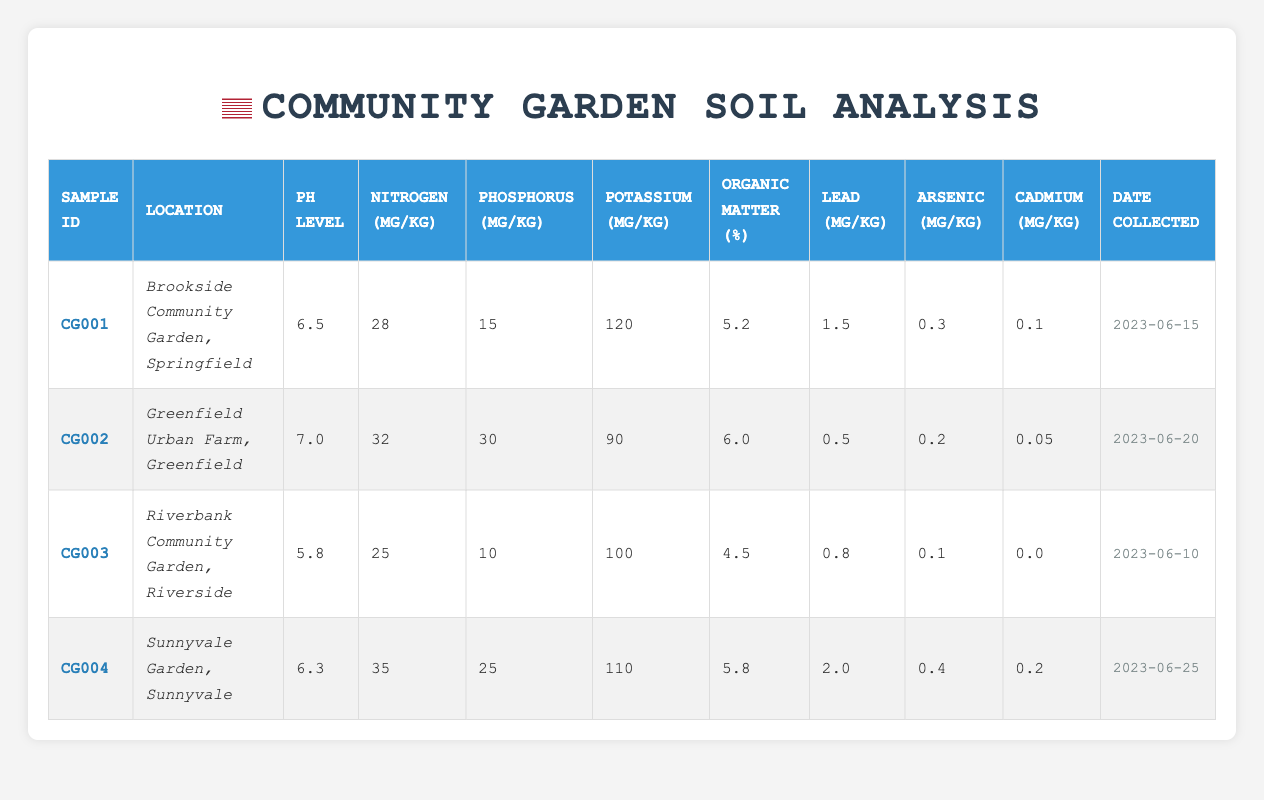What is the pH level of soil from the Greenfield Urban Farm? The pH level for the soil sample taken from the Greenfield Urban Farm (CG002) is listed directly in the table as 7.0.
Answer: 7.0 Which community garden has the highest nitrogen content, and what is that value? The nitrogen content for each garden is: Brookside (28 mg/kg), Greenfield (32 mg/kg), Riverbank (25 mg/kg), and Sunnyvale (35 mg/kg). The highest value is found in Sunnyvale at 35 mg/kg.
Answer: Sunnyvale, 35 mg/kg Is the lead content in the soil at Riverbank Community Garden greater than 1 mg/kg? The lead content at Riverbank (CG003) is listed as 0.8 mg/kg, which is less than 1 mg/kg. Therefore, the statement is false.
Answer: No What is the average potassium content across all community gardens sampled? The potassium values are: Brookside (120 mg/kg), Greenfield (90 mg/kg), Riverbank (100 mg/kg), and Sunnyvale (110 mg/kg). Adding these gives 120 + 90 + 100 + 110 = 420 mg/kg. There are 4 samples, so the average is 420 / 4 = 105 mg/kg.
Answer: 105 mg/kg What percentage of organic matter does the soil from the Brookside Community Garden contain? The organic matter percentage for Brookside (CG001) is explicitly mentioned in the table as 5.2%.
Answer: 5.2% Which community garden shows a decrease in both phosphorus and nitrogen content compared to the others? Riverbank (CG003) has the lowest nitrogen (25 mg/kg) and phosphorus (10 mg/kg) levels when compared to the others. Both values are lower than those of Brookside, Greenfield, and Sunnyvale. This makes Riverbank unique for these decreases.
Answer: Riverbank Community Garden Has any soil sample exceeded the acceptable lead limit of 2 mg/kg? The lead contents are Brookside (1.5 mg/kg), Greenfield (0.5 mg/kg), Riverbank (0.8 mg/kg), and Sunnyvale (2.0 mg/kg). The highest value (Sunnyvale at 2.0 mg/kg) does not exceed the limit, making the statement false.
Answer: No What was the date when the soil sample from Sunnyvale Garden was collected? The date listed for Sunnyvale Garden (CG004) is provided directly in the table as 2023-06-25.
Answer: 2023-06-25 